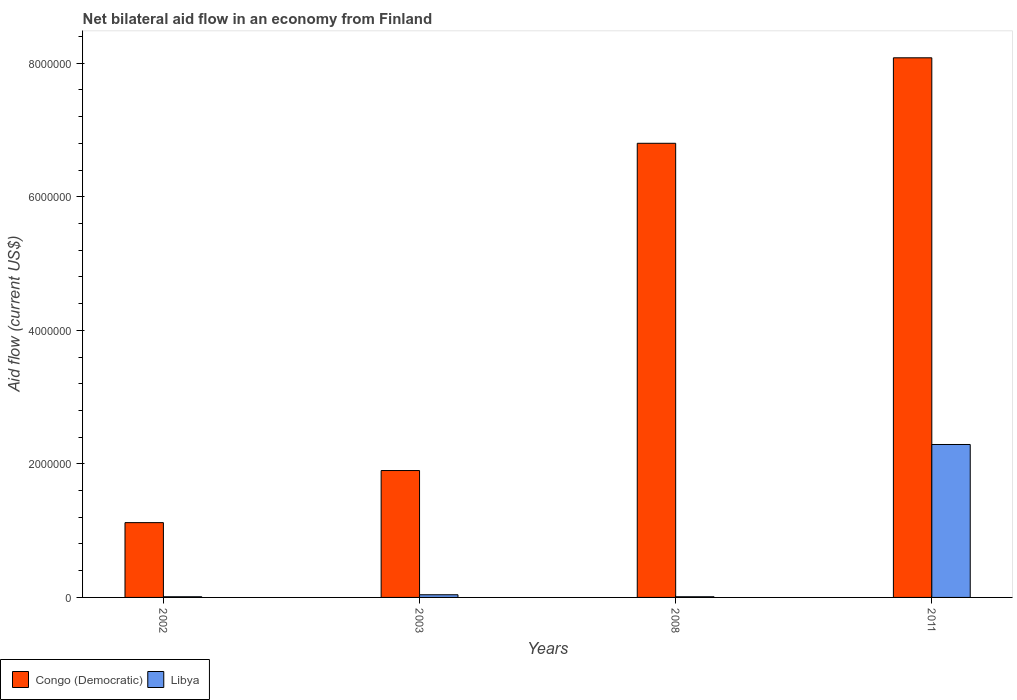How many different coloured bars are there?
Offer a terse response. 2. Are the number of bars per tick equal to the number of legend labels?
Give a very brief answer. Yes. How many bars are there on the 3rd tick from the left?
Offer a very short reply. 2. How many bars are there on the 3rd tick from the right?
Offer a terse response. 2. What is the label of the 4th group of bars from the left?
Your response must be concise. 2011. In how many cases, is the number of bars for a given year not equal to the number of legend labels?
Keep it short and to the point. 0. What is the net bilateral aid flow in Libya in 2011?
Give a very brief answer. 2.29e+06. Across all years, what is the maximum net bilateral aid flow in Libya?
Ensure brevity in your answer.  2.29e+06. Across all years, what is the minimum net bilateral aid flow in Libya?
Ensure brevity in your answer.  10000. In which year was the net bilateral aid flow in Libya minimum?
Keep it short and to the point. 2002. What is the total net bilateral aid flow in Congo (Democratic) in the graph?
Offer a terse response. 1.79e+07. What is the difference between the net bilateral aid flow in Congo (Democratic) in 2002 and that in 2008?
Make the answer very short. -5.68e+06. What is the difference between the net bilateral aid flow in Congo (Democratic) in 2011 and the net bilateral aid flow in Libya in 2002?
Provide a succinct answer. 8.07e+06. What is the average net bilateral aid flow in Congo (Democratic) per year?
Your answer should be compact. 4.48e+06. In the year 2003, what is the difference between the net bilateral aid flow in Libya and net bilateral aid flow in Congo (Democratic)?
Keep it short and to the point. -1.86e+06. In how many years, is the net bilateral aid flow in Congo (Democratic) greater than 5600000 US$?
Your answer should be compact. 2. What is the ratio of the net bilateral aid flow in Congo (Democratic) in 2003 to that in 2008?
Provide a short and direct response. 0.28. Is the net bilateral aid flow in Libya in 2008 less than that in 2011?
Offer a terse response. Yes. What is the difference between the highest and the second highest net bilateral aid flow in Libya?
Offer a terse response. 2.25e+06. What is the difference between the highest and the lowest net bilateral aid flow in Libya?
Give a very brief answer. 2.28e+06. In how many years, is the net bilateral aid flow in Libya greater than the average net bilateral aid flow in Libya taken over all years?
Your answer should be very brief. 1. What does the 1st bar from the left in 2002 represents?
Your answer should be compact. Congo (Democratic). What does the 2nd bar from the right in 2003 represents?
Provide a short and direct response. Congo (Democratic). Are the values on the major ticks of Y-axis written in scientific E-notation?
Ensure brevity in your answer.  No. Does the graph contain any zero values?
Make the answer very short. No. Where does the legend appear in the graph?
Provide a succinct answer. Bottom left. What is the title of the graph?
Your answer should be very brief. Net bilateral aid flow in an economy from Finland. What is the label or title of the Y-axis?
Your answer should be very brief. Aid flow (current US$). What is the Aid flow (current US$) of Congo (Democratic) in 2002?
Provide a succinct answer. 1.12e+06. What is the Aid flow (current US$) in Congo (Democratic) in 2003?
Give a very brief answer. 1.90e+06. What is the Aid flow (current US$) of Libya in 2003?
Give a very brief answer. 4.00e+04. What is the Aid flow (current US$) in Congo (Democratic) in 2008?
Give a very brief answer. 6.80e+06. What is the Aid flow (current US$) in Congo (Democratic) in 2011?
Provide a succinct answer. 8.08e+06. What is the Aid flow (current US$) in Libya in 2011?
Provide a succinct answer. 2.29e+06. Across all years, what is the maximum Aid flow (current US$) in Congo (Democratic)?
Give a very brief answer. 8.08e+06. Across all years, what is the maximum Aid flow (current US$) in Libya?
Offer a terse response. 2.29e+06. Across all years, what is the minimum Aid flow (current US$) in Congo (Democratic)?
Offer a terse response. 1.12e+06. What is the total Aid flow (current US$) of Congo (Democratic) in the graph?
Your response must be concise. 1.79e+07. What is the total Aid flow (current US$) in Libya in the graph?
Provide a short and direct response. 2.35e+06. What is the difference between the Aid flow (current US$) of Congo (Democratic) in 2002 and that in 2003?
Your answer should be very brief. -7.80e+05. What is the difference between the Aid flow (current US$) of Libya in 2002 and that in 2003?
Your answer should be very brief. -3.00e+04. What is the difference between the Aid flow (current US$) in Congo (Democratic) in 2002 and that in 2008?
Offer a terse response. -5.68e+06. What is the difference between the Aid flow (current US$) of Congo (Democratic) in 2002 and that in 2011?
Your response must be concise. -6.96e+06. What is the difference between the Aid flow (current US$) in Libya in 2002 and that in 2011?
Ensure brevity in your answer.  -2.28e+06. What is the difference between the Aid flow (current US$) in Congo (Democratic) in 2003 and that in 2008?
Ensure brevity in your answer.  -4.90e+06. What is the difference between the Aid flow (current US$) of Libya in 2003 and that in 2008?
Provide a succinct answer. 3.00e+04. What is the difference between the Aid flow (current US$) of Congo (Democratic) in 2003 and that in 2011?
Provide a succinct answer. -6.18e+06. What is the difference between the Aid flow (current US$) in Libya in 2003 and that in 2011?
Your response must be concise. -2.25e+06. What is the difference between the Aid flow (current US$) in Congo (Democratic) in 2008 and that in 2011?
Keep it short and to the point. -1.28e+06. What is the difference between the Aid flow (current US$) of Libya in 2008 and that in 2011?
Offer a terse response. -2.28e+06. What is the difference between the Aid flow (current US$) of Congo (Democratic) in 2002 and the Aid flow (current US$) of Libya in 2003?
Ensure brevity in your answer.  1.08e+06. What is the difference between the Aid flow (current US$) in Congo (Democratic) in 2002 and the Aid flow (current US$) in Libya in 2008?
Offer a very short reply. 1.11e+06. What is the difference between the Aid flow (current US$) in Congo (Democratic) in 2002 and the Aid flow (current US$) in Libya in 2011?
Your answer should be compact. -1.17e+06. What is the difference between the Aid flow (current US$) of Congo (Democratic) in 2003 and the Aid flow (current US$) of Libya in 2008?
Make the answer very short. 1.89e+06. What is the difference between the Aid flow (current US$) of Congo (Democratic) in 2003 and the Aid flow (current US$) of Libya in 2011?
Your answer should be compact. -3.90e+05. What is the difference between the Aid flow (current US$) of Congo (Democratic) in 2008 and the Aid flow (current US$) of Libya in 2011?
Keep it short and to the point. 4.51e+06. What is the average Aid flow (current US$) of Congo (Democratic) per year?
Give a very brief answer. 4.48e+06. What is the average Aid flow (current US$) of Libya per year?
Keep it short and to the point. 5.88e+05. In the year 2002, what is the difference between the Aid flow (current US$) of Congo (Democratic) and Aid flow (current US$) of Libya?
Give a very brief answer. 1.11e+06. In the year 2003, what is the difference between the Aid flow (current US$) in Congo (Democratic) and Aid flow (current US$) in Libya?
Provide a short and direct response. 1.86e+06. In the year 2008, what is the difference between the Aid flow (current US$) of Congo (Democratic) and Aid flow (current US$) of Libya?
Keep it short and to the point. 6.79e+06. In the year 2011, what is the difference between the Aid flow (current US$) in Congo (Democratic) and Aid flow (current US$) in Libya?
Ensure brevity in your answer.  5.79e+06. What is the ratio of the Aid flow (current US$) in Congo (Democratic) in 2002 to that in 2003?
Provide a short and direct response. 0.59. What is the ratio of the Aid flow (current US$) of Libya in 2002 to that in 2003?
Make the answer very short. 0.25. What is the ratio of the Aid flow (current US$) of Congo (Democratic) in 2002 to that in 2008?
Provide a short and direct response. 0.16. What is the ratio of the Aid flow (current US$) in Libya in 2002 to that in 2008?
Ensure brevity in your answer.  1. What is the ratio of the Aid flow (current US$) in Congo (Democratic) in 2002 to that in 2011?
Make the answer very short. 0.14. What is the ratio of the Aid flow (current US$) of Libya in 2002 to that in 2011?
Provide a succinct answer. 0. What is the ratio of the Aid flow (current US$) in Congo (Democratic) in 2003 to that in 2008?
Keep it short and to the point. 0.28. What is the ratio of the Aid flow (current US$) in Congo (Democratic) in 2003 to that in 2011?
Offer a terse response. 0.24. What is the ratio of the Aid flow (current US$) in Libya in 2003 to that in 2011?
Make the answer very short. 0.02. What is the ratio of the Aid flow (current US$) of Congo (Democratic) in 2008 to that in 2011?
Offer a very short reply. 0.84. What is the ratio of the Aid flow (current US$) of Libya in 2008 to that in 2011?
Offer a very short reply. 0. What is the difference between the highest and the second highest Aid flow (current US$) of Congo (Democratic)?
Keep it short and to the point. 1.28e+06. What is the difference between the highest and the second highest Aid flow (current US$) of Libya?
Provide a short and direct response. 2.25e+06. What is the difference between the highest and the lowest Aid flow (current US$) of Congo (Democratic)?
Offer a very short reply. 6.96e+06. What is the difference between the highest and the lowest Aid flow (current US$) of Libya?
Provide a short and direct response. 2.28e+06. 